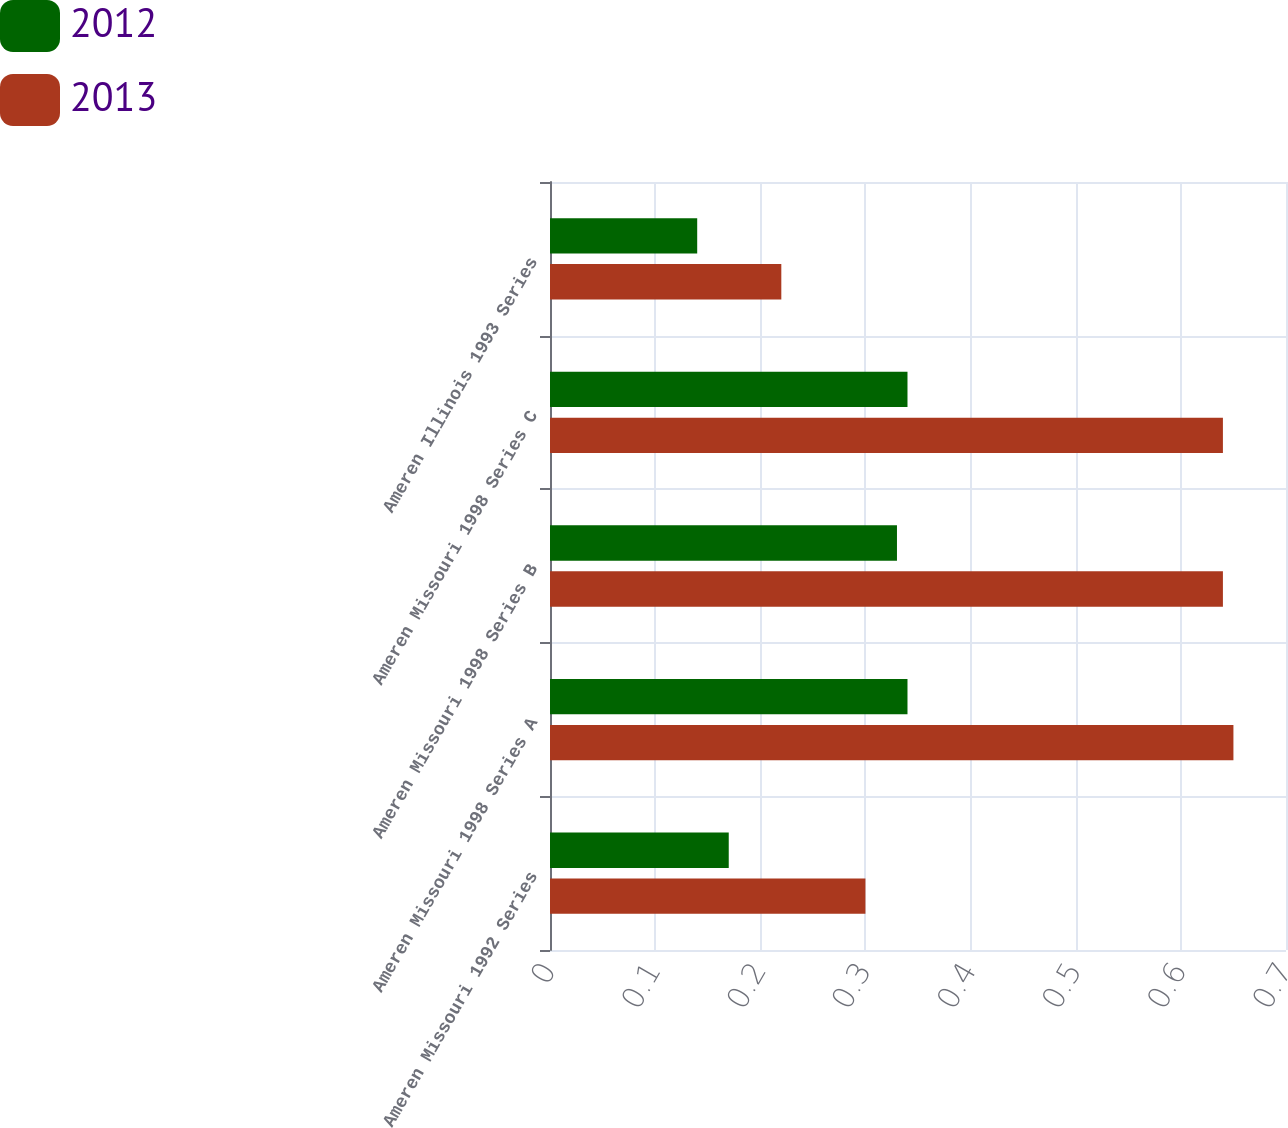<chart> <loc_0><loc_0><loc_500><loc_500><stacked_bar_chart><ecel><fcel>Ameren Missouri 1992 Series<fcel>Ameren Missouri 1998 Series A<fcel>Ameren Missouri 1998 Series B<fcel>Ameren Missouri 1998 Series C<fcel>Ameren Illinois 1993 Series<nl><fcel>2012<fcel>0.17<fcel>0.34<fcel>0.33<fcel>0.34<fcel>0.14<nl><fcel>2013<fcel>0.3<fcel>0.65<fcel>0.64<fcel>0.64<fcel>0.22<nl></chart> 